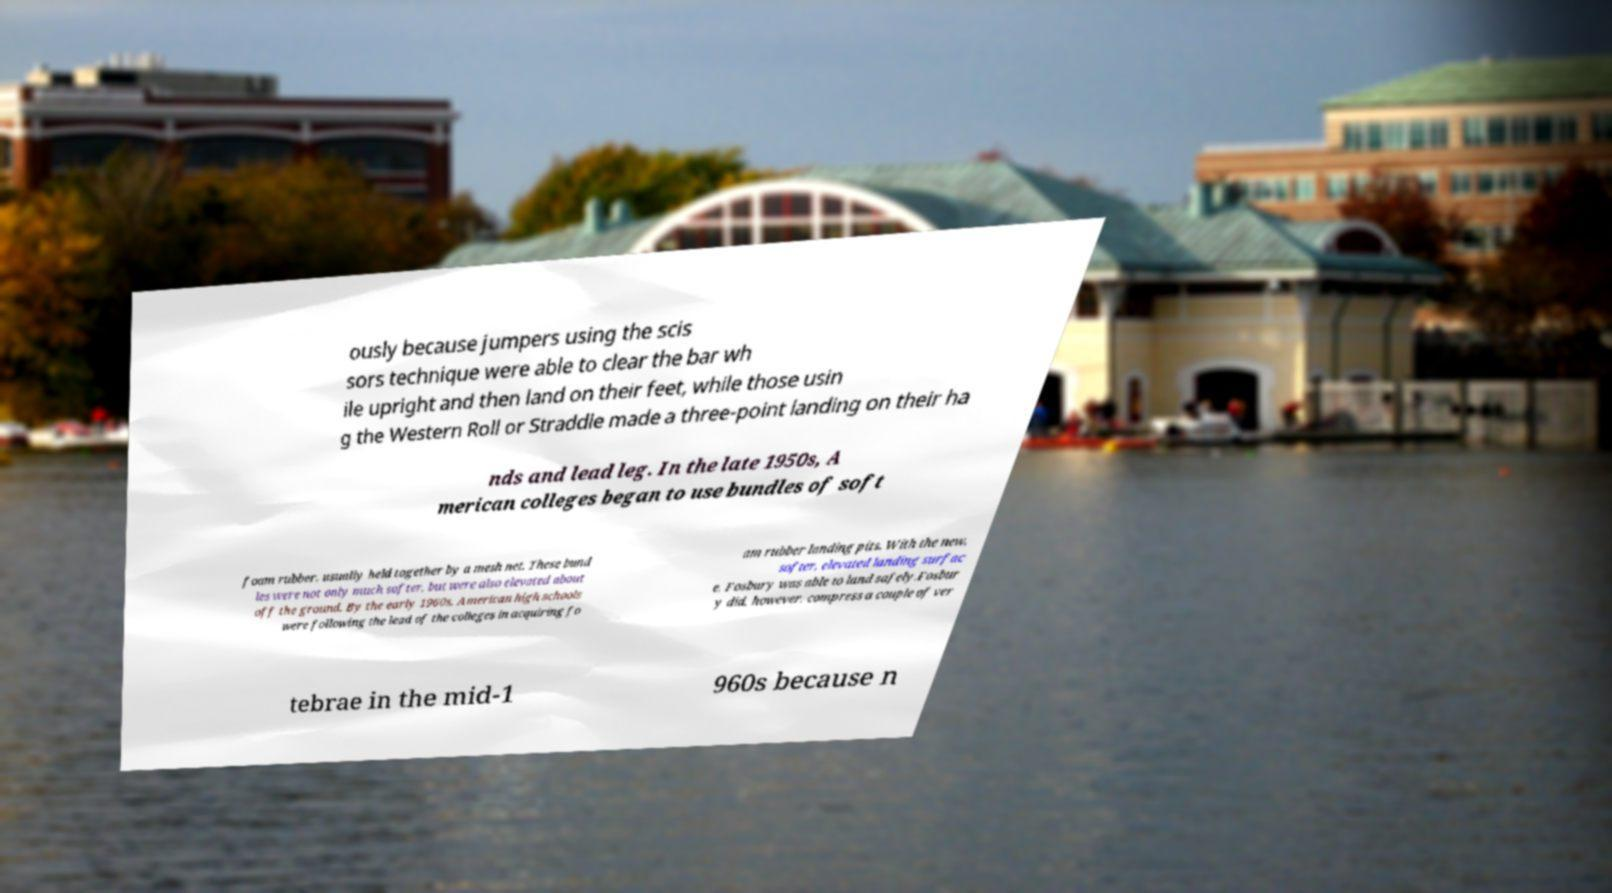Could you assist in decoding the text presented in this image and type it out clearly? ously because jumpers using the scis sors technique were able to clear the bar wh ile upright and then land on their feet, while those usin g the Western Roll or Straddle made a three-point landing on their ha nds and lead leg. In the late 1950s, A merican colleges began to use bundles of soft foam rubber, usually held together by a mesh net. These bund les were not only much softer, but were also elevated about off the ground. By the early 1960s, American high schools were following the lead of the colleges in acquiring fo am rubber landing pits. With the new, softer, elevated landing surfac e, Fosbury was able to land safely.Fosbur y did, however, compress a couple of ver tebrae in the mid-1 960s because n 